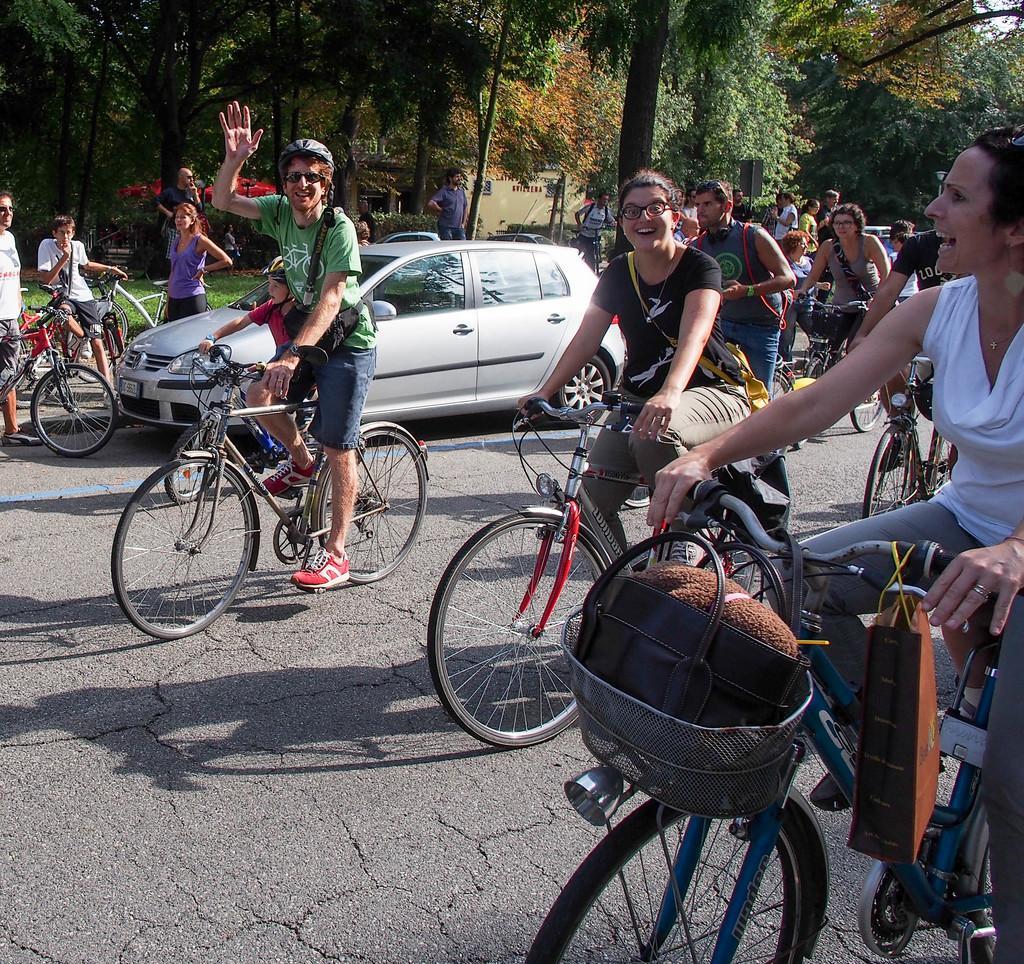In one or two sentences, can you explain what this image depicts? In this image some of persons they are the cycles on the ground behind the person the car is parked behind the person some trees are there and background is greenery. 